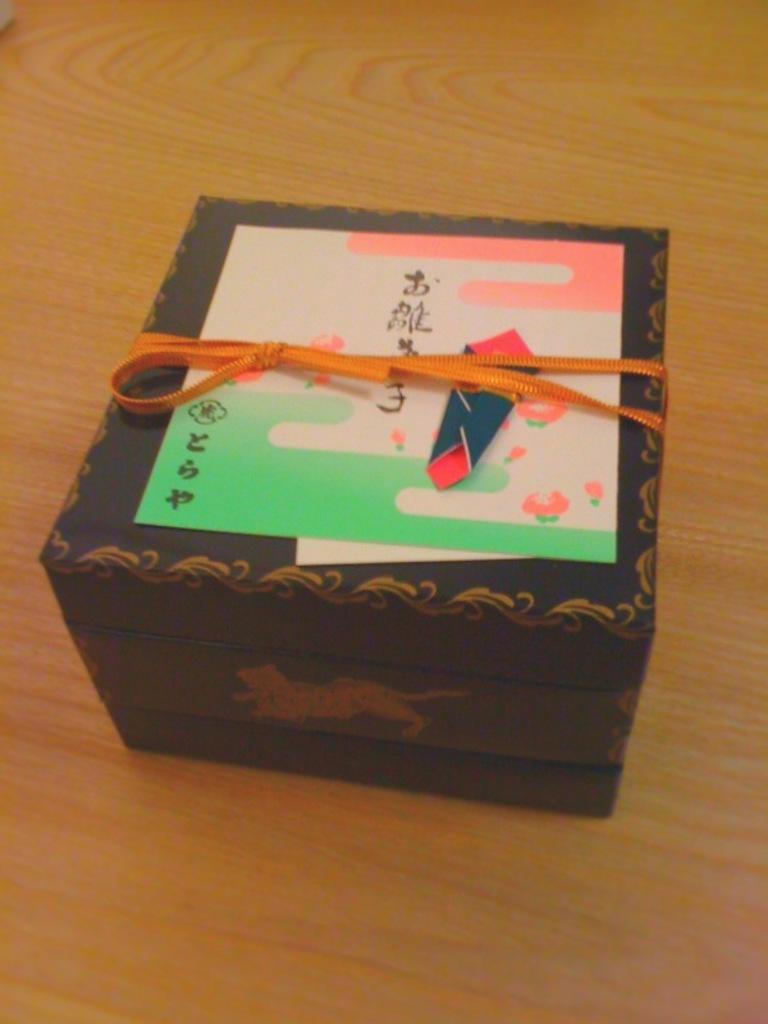Provide a one-sentence caption for the provided image. A gift in a box with a creature on the side on the top there is a card which is written in some asian language. 